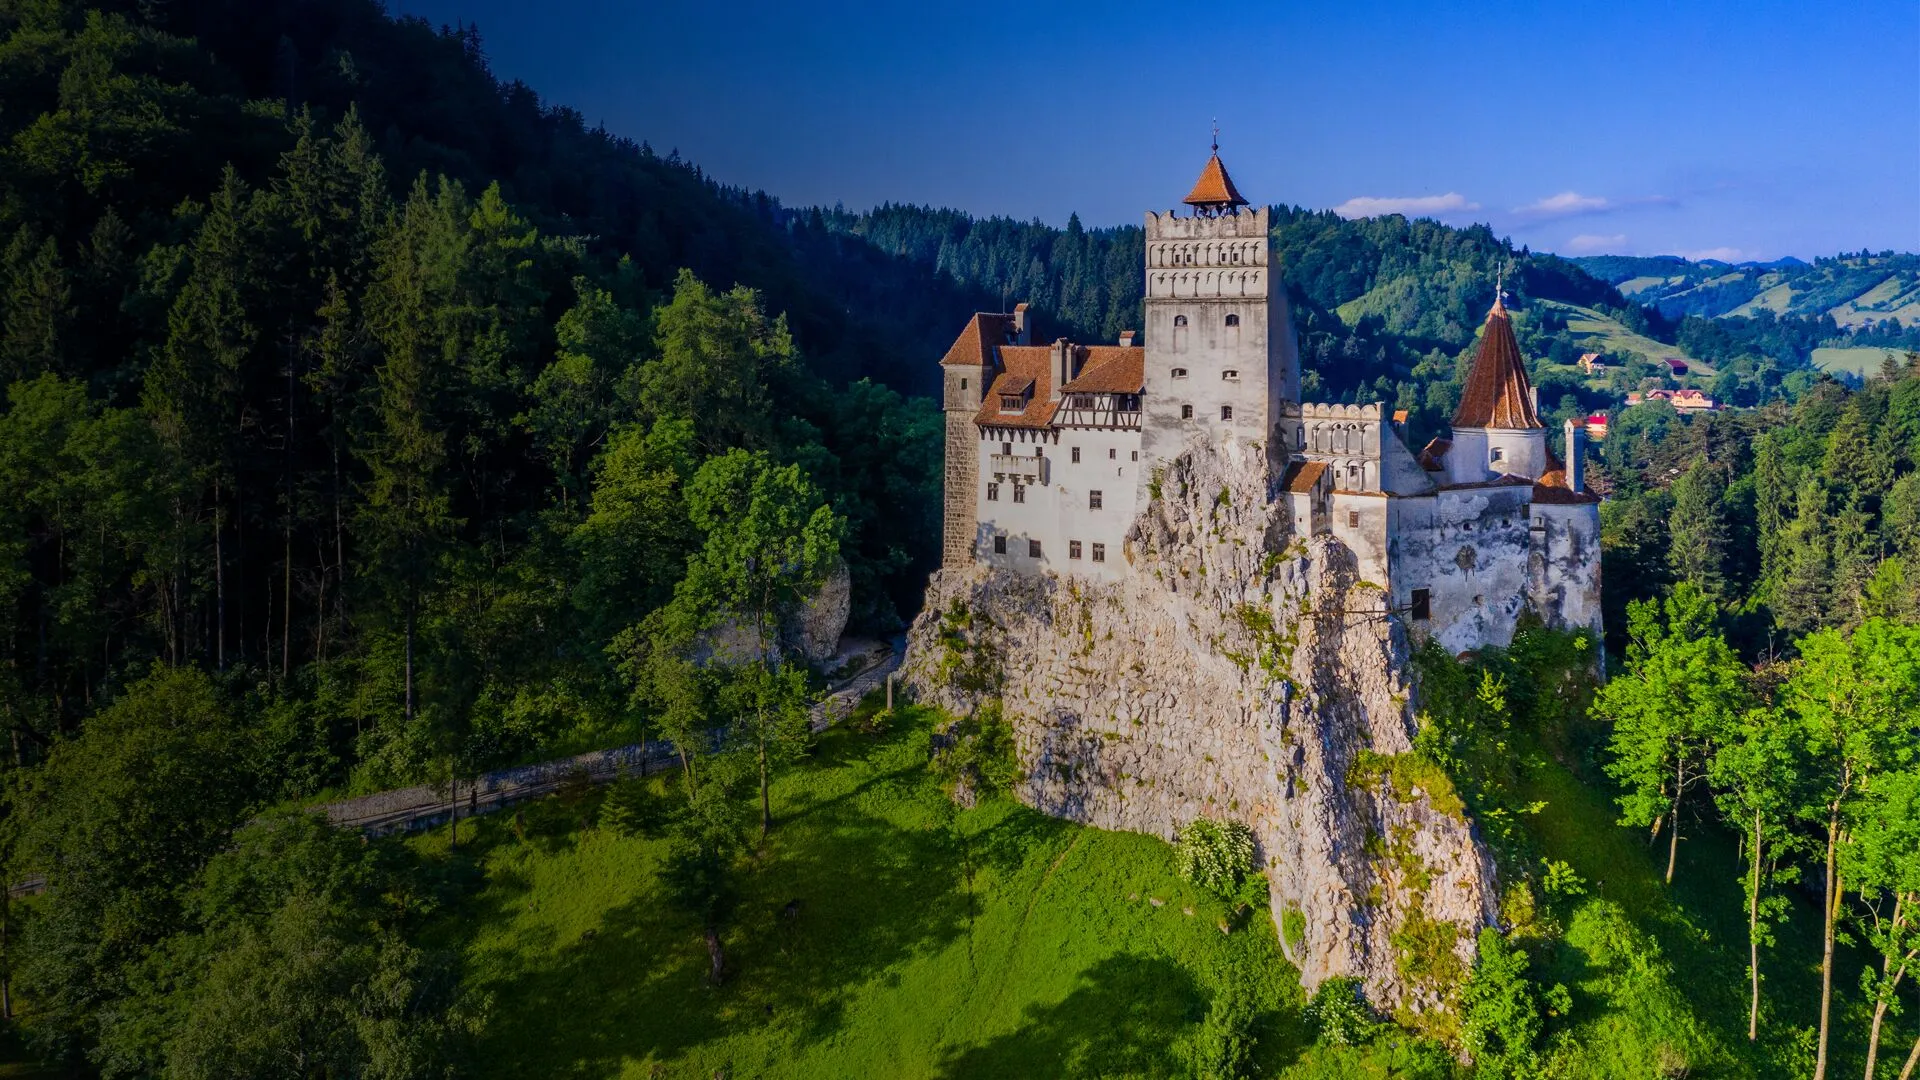Can you tell me more about the surrounding landscape of the castle? The surrounding landscape of Bran Castle is a picturesque and serene expanse that complements the majestic fortress. The castle is set amidst dense, verdant forests that provide a rich green backdrop, making the castle's white walls and orange-tiled roof stand out strikingly. To the east, the forest stretches far and wide, blending into the distant horizon with subtle variations in color from deep emerald to lighter shades of green. To the west, the landscape transitions into rolling hills and scattered rural villages, each with their own charm and character. The scenic beauty is enhanced by the rugged cliffs upon which the castle is perched, offering stunning panoramic views of the lush valleys and distant Carpathian Mountains. The interplay of light and shadow throughout the day creates a dynamic and ever-changing scene, while the peaceful ambiance of this natural setting underscores the castle's historic and strategic significance. 